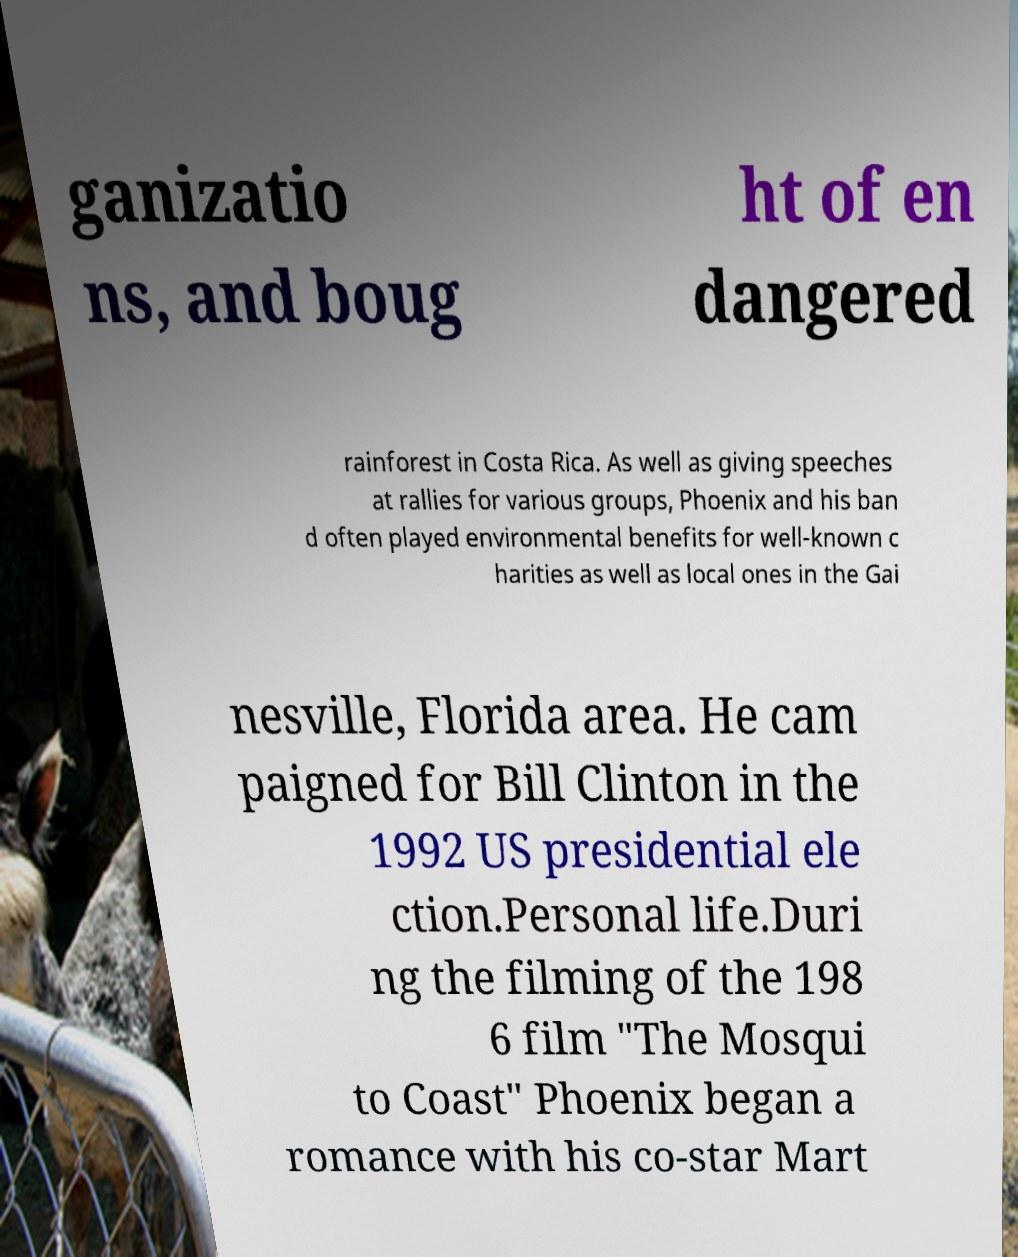Please identify and transcribe the text found in this image. ganizatio ns, and boug ht of en dangered rainforest in Costa Rica. As well as giving speeches at rallies for various groups, Phoenix and his ban d often played environmental benefits for well-known c harities as well as local ones in the Gai nesville, Florida area. He cam paigned for Bill Clinton in the 1992 US presidential ele ction.Personal life.Duri ng the filming of the 198 6 film "The Mosqui to Coast" Phoenix began a romance with his co-star Mart 